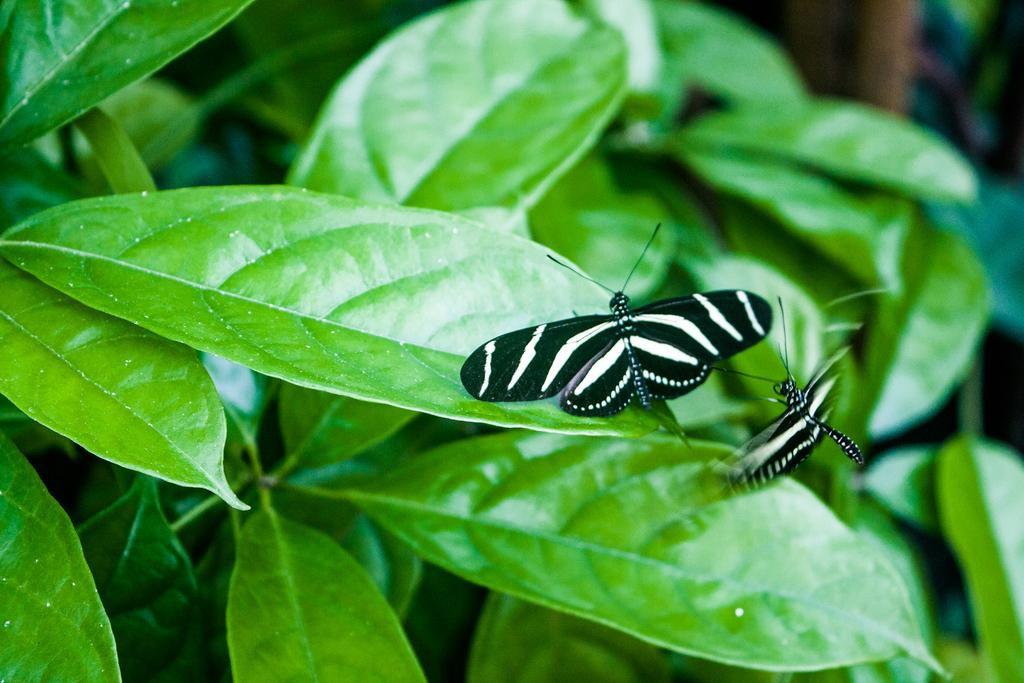What can be seen on the leaves in the image? There are insects on the leaves in the image. Can you describe the surroundings of the insects? There are blurred things on the right side of the insects in the image. What type of spark can be seen coming from the insects in the image? There is no spark present in the image; it features insects on leaves with blurred things on the right side. 